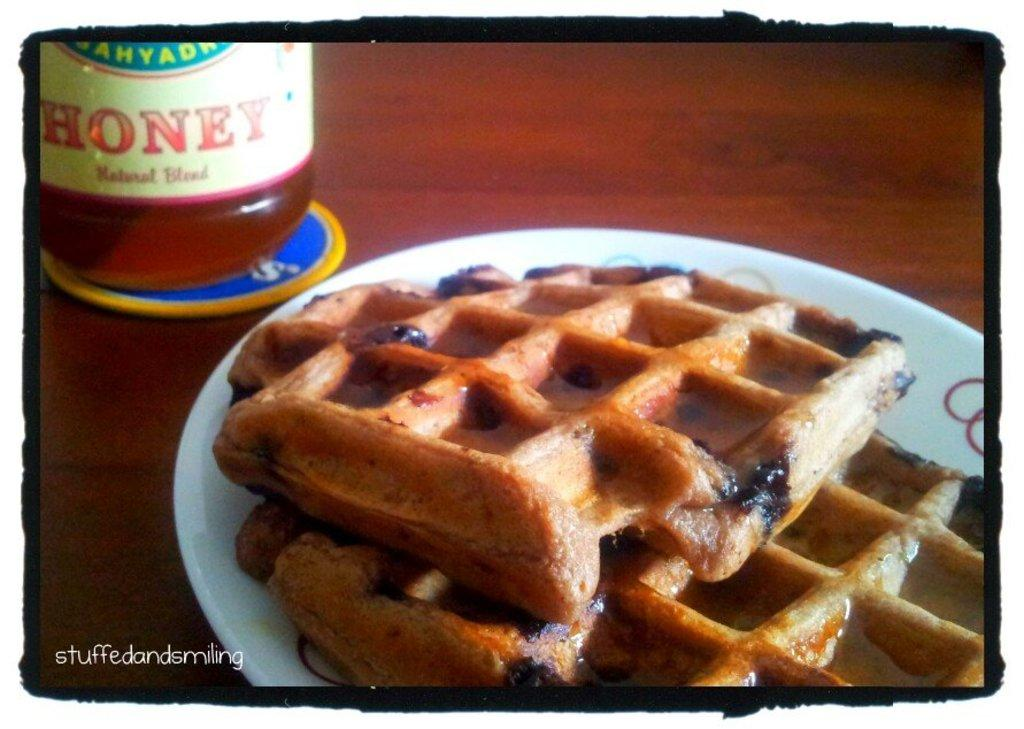What is on the plate in the image? There is a waffle on a plate in the image. What is on the table in the image? There is a honey bottle on the table in the image. Can you describe any additional features of the image? Yes, there is a watermark on the image. What type of paste is being used to respect the waffle in the image? There is no paste or respect being shown to the waffle in the image; it is simply a waffle on a plate with a honey bottle nearby. 